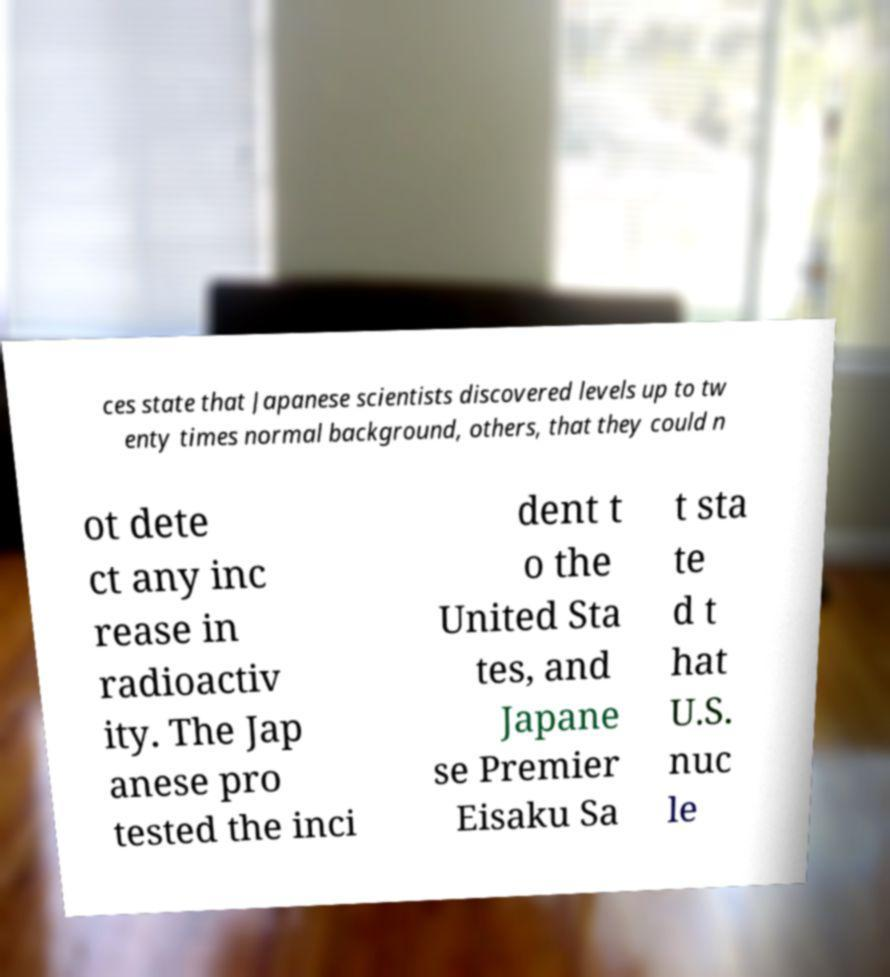Can you read and provide the text displayed in the image?This photo seems to have some interesting text. Can you extract and type it out for me? ces state that Japanese scientists discovered levels up to tw enty times normal background, others, that they could n ot dete ct any inc rease in radioactiv ity. The Jap anese pro tested the inci dent t o the United Sta tes, and Japane se Premier Eisaku Sa t sta te d t hat U.S. nuc le 